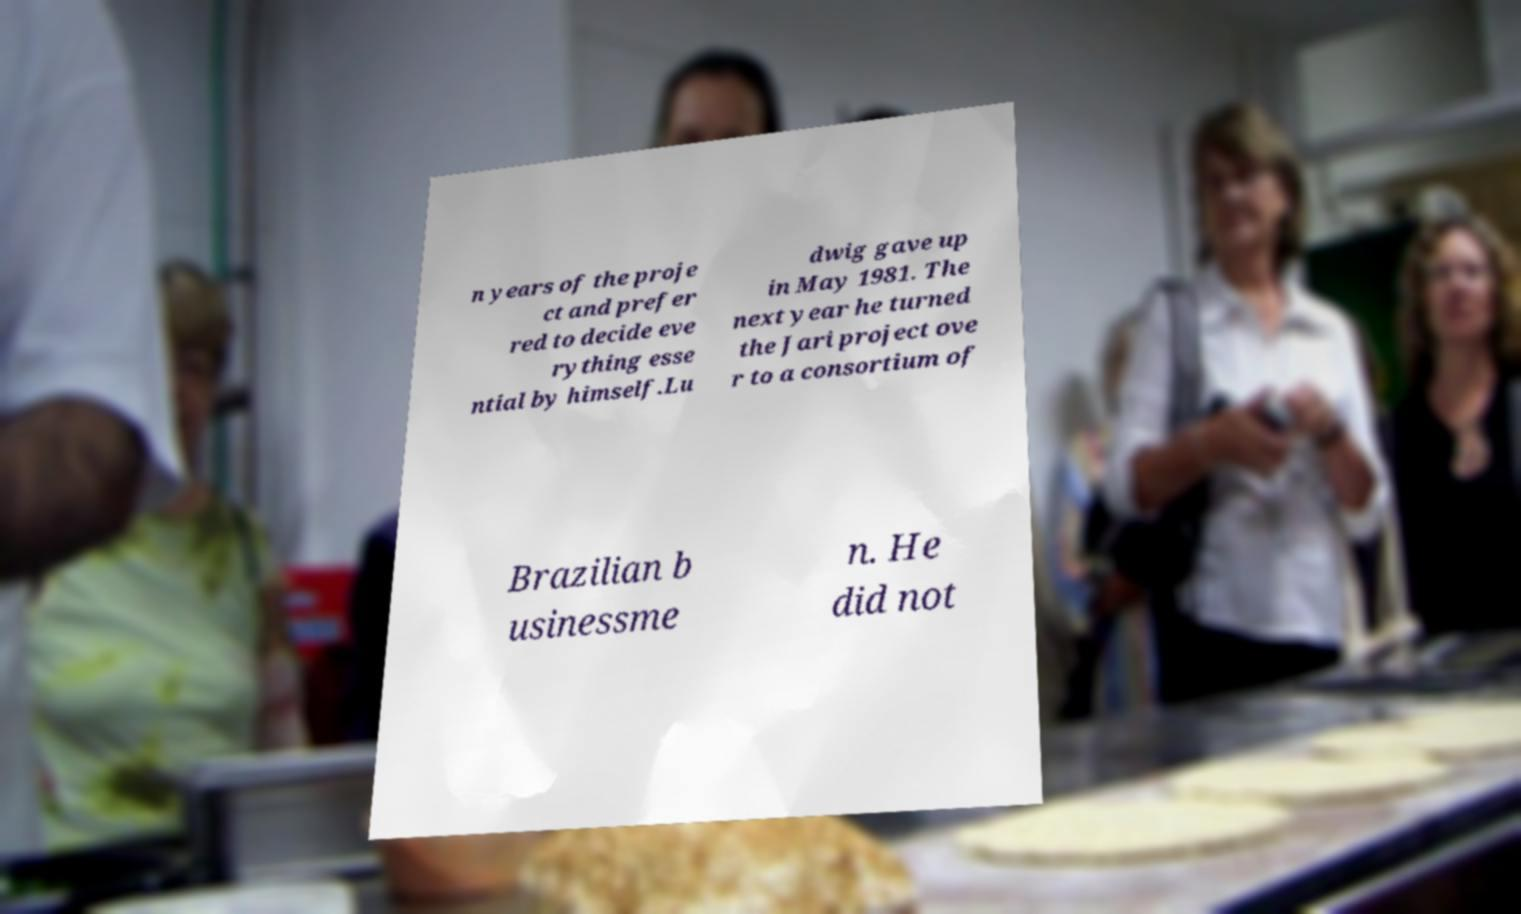Could you extract and type out the text from this image? n years of the proje ct and prefer red to decide eve rything esse ntial by himself.Lu dwig gave up in May 1981. The next year he turned the Jari project ove r to a consortium of Brazilian b usinessme n. He did not 